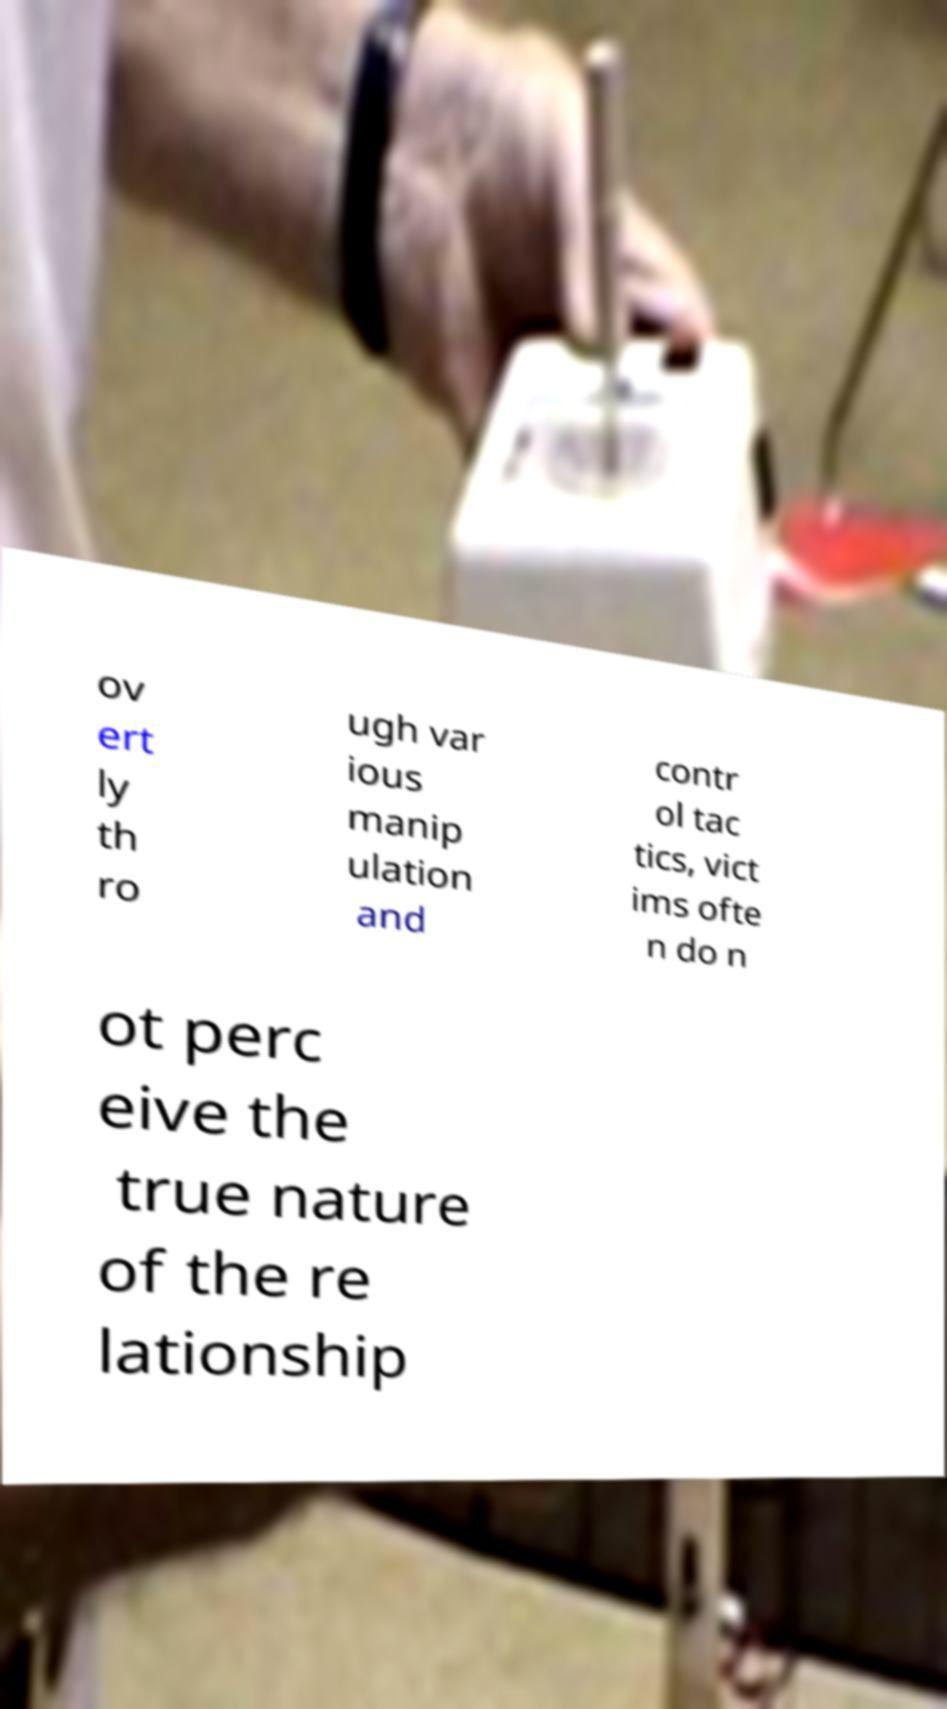Could you assist in decoding the text presented in this image and type it out clearly? ov ert ly th ro ugh var ious manip ulation and contr ol tac tics, vict ims ofte n do n ot perc eive the true nature of the re lationship 